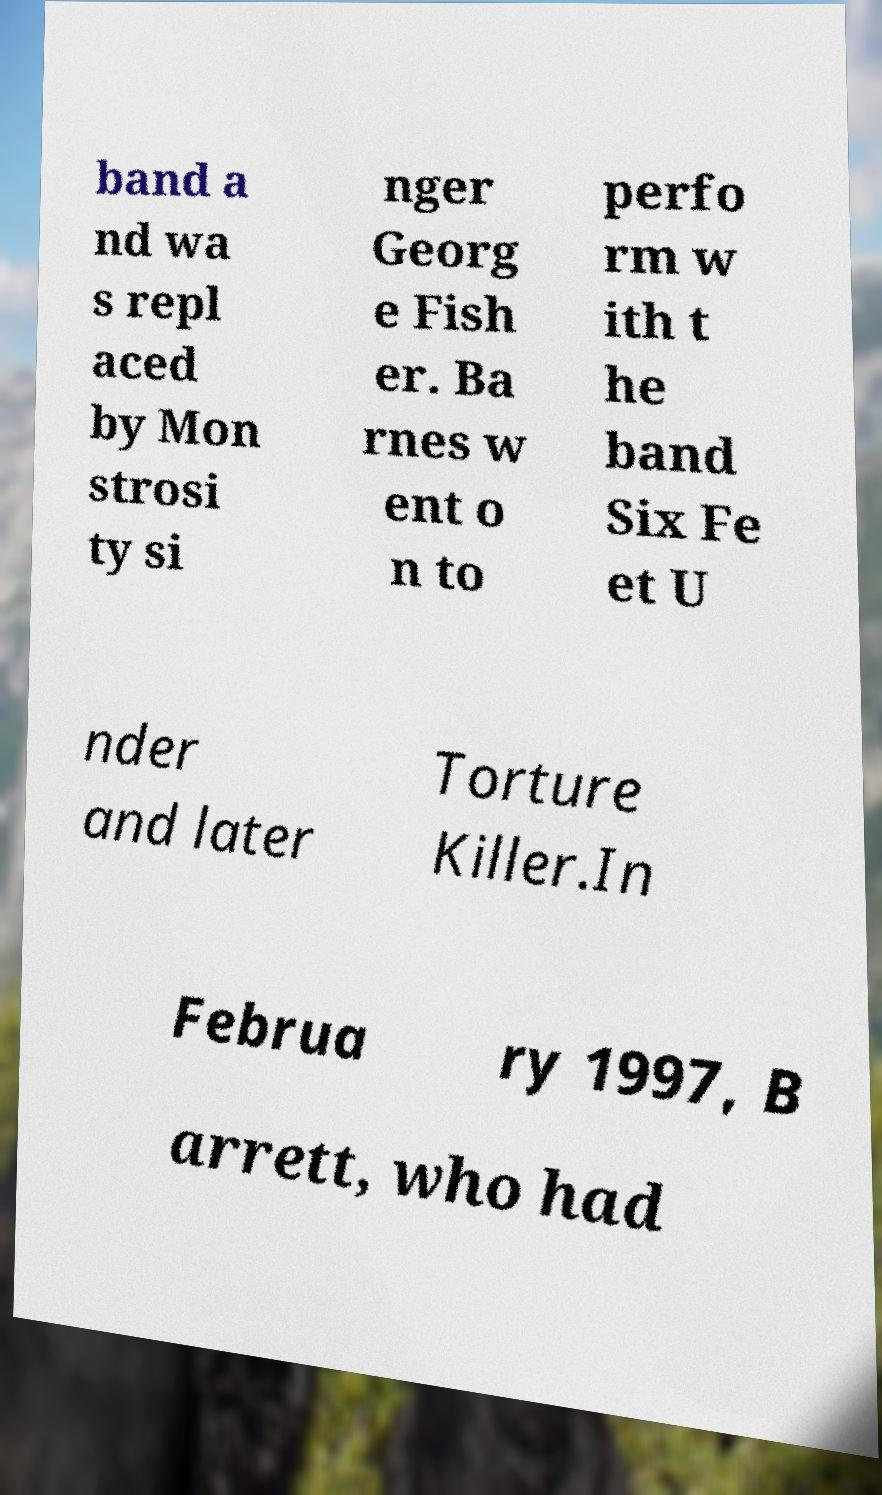Please read and relay the text visible in this image. What does it say? band a nd wa s repl aced by Mon strosi ty si nger Georg e Fish er. Ba rnes w ent o n to perfo rm w ith t he band Six Fe et U nder and later Torture Killer.In Februa ry 1997, B arrett, who had 